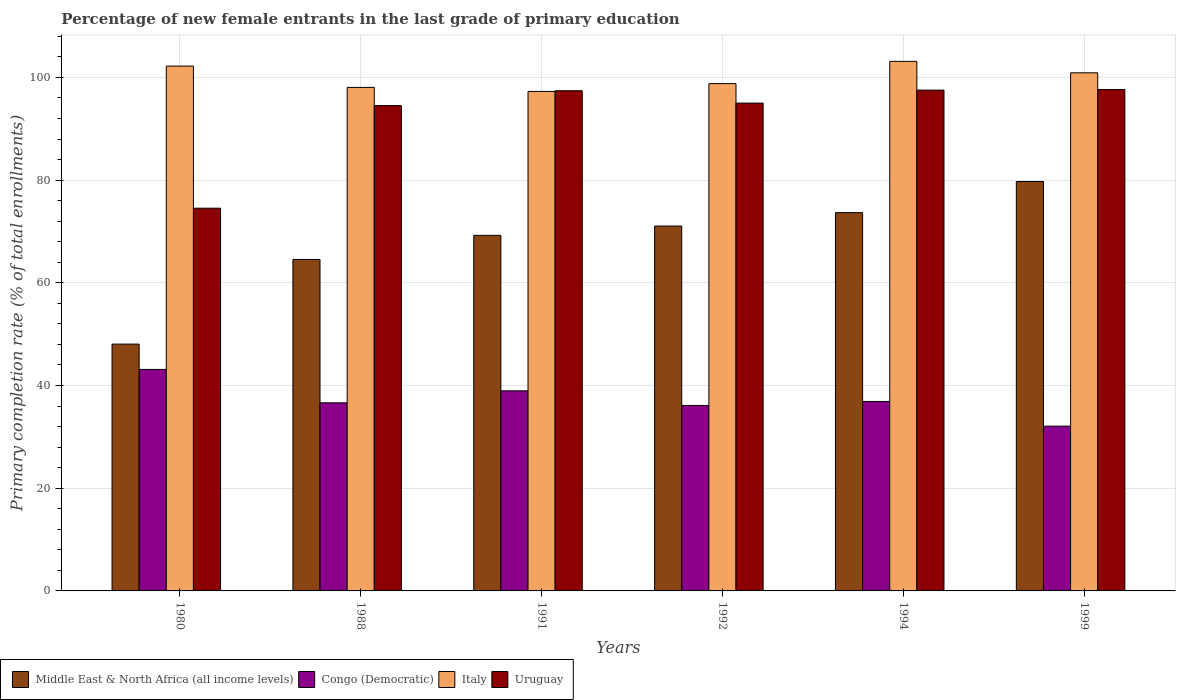Are the number of bars on each tick of the X-axis equal?
Your answer should be very brief. Yes. What is the label of the 5th group of bars from the left?
Keep it short and to the point. 1994. In how many cases, is the number of bars for a given year not equal to the number of legend labels?
Ensure brevity in your answer.  0. What is the percentage of new female entrants in Middle East & North Africa (all income levels) in 1992?
Your answer should be very brief. 71.06. Across all years, what is the maximum percentage of new female entrants in Middle East & North Africa (all income levels)?
Your response must be concise. 79.73. Across all years, what is the minimum percentage of new female entrants in Uruguay?
Your answer should be very brief. 74.53. In which year was the percentage of new female entrants in Italy maximum?
Your answer should be compact. 1994. In which year was the percentage of new female entrants in Uruguay minimum?
Ensure brevity in your answer.  1980. What is the total percentage of new female entrants in Middle East & North Africa (all income levels) in the graph?
Make the answer very short. 406.31. What is the difference between the percentage of new female entrants in Middle East & North Africa (all income levels) in 1991 and that in 1994?
Your answer should be compact. -4.42. What is the difference between the percentage of new female entrants in Congo (Democratic) in 1994 and the percentage of new female entrants in Middle East & North Africa (all income levels) in 1980?
Your answer should be compact. -11.17. What is the average percentage of new female entrants in Uruguay per year?
Your response must be concise. 92.77. In the year 1992, what is the difference between the percentage of new female entrants in Middle East & North Africa (all income levels) and percentage of new female entrants in Uruguay?
Keep it short and to the point. -23.94. In how many years, is the percentage of new female entrants in Congo (Democratic) greater than 60 %?
Keep it short and to the point. 0. What is the ratio of the percentage of new female entrants in Uruguay in 1980 to that in 1994?
Your answer should be compact. 0.76. Is the difference between the percentage of new female entrants in Middle East & North Africa (all income levels) in 1991 and 1999 greater than the difference between the percentage of new female entrants in Uruguay in 1991 and 1999?
Your answer should be very brief. No. What is the difference between the highest and the second highest percentage of new female entrants in Middle East & North Africa (all income levels)?
Ensure brevity in your answer.  6.06. What is the difference between the highest and the lowest percentage of new female entrants in Middle East & North Africa (all income levels)?
Make the answer very short. 31.66. Is the sum of the percentage of new female entrants in Congo (Democratic) in 1988 and 1992 greater than the maximum percentage of new female entrants in Uruguay across all years?
Provide a succinct answer. No. What does the 3rd bar from the left in 1992 represents?
Make the answer very short. Italy. What does the 4th bar from the right in 1999 represents?
Give a very brief answer. Middle East & North Africa (all income levels). Is it the case that in every year, the sum of the percentage of new female entrants in Italy and percentage of new female entrants in Middle East & North Africa (all income levels) is greater than the percentage of new female entrants in Congo (Democratic)?
Give a very brief answer. Yes. How many years are there in the graph?
Offer a very short reply. 6. Are the values on the major ticks of Y-axis written in scientific E-notation?
Make the answer very short. No. Does the graph contain grids?
Keep it short and to the point. Yes. Where does the legend appear in the graph?
Ensure brevity in your answer.  Bottom left. How many legend labels are there?
Make the answer very short. 4. How are the legend labels stacked?
Offer a terse response. Horizontal. What is the title of the graph?
Give a very brief answer. Percentage of new female entrants in the last grade of primary education. Does "Sierra Leone" appear as one of the legend labels in the graph?
Your answer should be very brief. No. What is the label or title of the Y-axis?
Keep it short and to the point. Primary completion rate (% of total enrollments). What is the Primary completion rate (% of total enrollments) of Middle East & North Africa (all income levels) in 1980?
Your answer should be very brief. 48.07. What is the Primary completion rate (% of total enrollments) in Congo (Democratic) in 1980?
Offer a very short reply. 43.14. What is the Primary completion rate (% of total enrollments) in Italy in 1980?
Your answer should be very brief. 102.2. What is the Primary completion rate (% of total enrollments) of Uruguay in 1980?
Your answer should be very brief. 74.53. What is the Primary completion rate (% of total enrollments) of Middle East & North Africa (all income levels) in 1988?
Offer a terse response. 64.55. What is the Primary completion rate (% of total enrollments) of Congo (Democratic) in 1988?
Ensure brevity in your answer.  36.63. What is the Primary completion rate (% of total enrollments) of Italy in 1988?
Ensure brevity in your answer.  98.06. What is the Primary completion rate (% of total enrollments) in Uruguay in 1988?
Your answer should be compact. 94.51. What is the Primary completion rate (% of total enrollments) of Middle East & North Africa (all income levels) in 1991?
Keep it short and to the point. 69.24. What is the Primary completion rate (% of total enrollments) of Congo (Democratic) in 1991?
Give a very brief answer. 38.96. What is the Primary completion rate (% of total enrollments) of Italy in 1991?
Provide a succinct answer. 97.27. What is the Primary completion rate (% of total enrollments) of Uruguay in 1991?
Offer a very short reply. 97.4. What is the Primary completion rate (% of total enrollments) in Middle East & North Africa (all income levels) in 1992?
Offer a very short reply. 71.06. What is the Primary completion rate (% of total enrollments) in Congo (Democratic) in 1992?
Offer a terse response. 36.12. What is the Primary completion rate (% of total enrollments) of Italy in 1992?
Offer a terse response. 98.79. What is the Primary completion rate (% of total enrollments) of Uruguay in 1992?
Keep it short and to the point. 95. What is the Primary completion rate (% of total enrollments) of Middle East & North Africa (all income levels) in 1994?
Ensure brevity in your answer.  73.67. What is the Primary completion rate (% of total enrollments) of Congo (Democratic) in 1994?
Provide a succinct answer. 36.89. What is the Primary completion rate (% of total enrollments) in Italy in 1994?
Offer a very short reply. 103.13. What is the Primary completion rate (% of total enrollments) in Uruguay in 1994?
Provide a succinct answer. 97.53. What is the Primary completion rate (% of total enrollments) of Middle East & North Africa (all income levels) in 1999?
Give a very brief answer. 79.73. What is the Primary completion rate (% of total enrollments) in Congo (Democratic) in 1999?
Offer a very short reply. 32.09. What is the Primary completion rate (% of total enrollments) of Italy in 1999?
Your response must be concise. 100.9. What is the Primary completion rate (% of total enrollments) of Uruguay in 1999?
Your answer should be compact. 97.64. Across all years, what is the maximum Primary completion rate (% of total enrollments) of Middle East & North Africa (all income levels)?
Your answer should be very brief. 79.73. Across all years, what is the maximum Primary completion rate (% of total enrollments) in Congo (Democratic)?
Offer a terse response. 43.14. Across all years, what is the maximum Primary completion rate (% of total enrollments) in Italy?
Your response must be concise. 103.13. Across all years, what is the maximum Primary completion rate (% of total enrollments) of Uruguay?
Make the answer very short. 97.64. Across all years, what is the minimum Primary completion rate (% of total enrollments) in Middle East & North Africa (all income levels)?
Offer a very short reply. 48.07. Across all years, what is the minimum Primary completion rate (% of total enrollments) of Congo (Democratic)?
Ensure brevity in your answer.  32.09. Across all years, what is the minimum Primary completion rate (% of total enrollments) in Italy?
Your response must be concise. 97.27. Across all years, what is the minimum Primary completion rate (% of total enrollments) of Uruguay?
Offer a very short reply. 74.53. What is the total Primary completion rate (% of total enrollments) of Middle East & North Africa (all income levels) in the graph?
Your response must be concise. 406.31. What is the total Primary completion rate (% of total enrollments) of Congo (Democratic) in the graph?
Offer a terse response. 223.83. What is the total Primary completion rate (% of total enrollments) of Italy in the graph?
Your answer should be very brief. 600.35. What is the total Primary completion rate (% of total enrollments) in Uruguay in the graph?
Offer a terse response. 556.6. What is the difference between the Primary completion rate (% of total enrollments) of Middle East & North Africa (all income levels) in 1980 and that in 1988?
Make the answer very short. -16.48. What is the difference between the Primary completion rate (% of total enrollments) of Congo (Democratic) in 1980 and that in 1988?
Give a very brief answer. 6.51. What is the difference between the Primary completion rate (% of total enrollments) in Italy in 1980 and that in 1988?
Your answer should be very brief. 4.15. What is the difference between the Primary completion rate (% of total enrollments) in Uruguay in 1980 and that in 1988?
Offer a terse response. -19.98. What is the difference between the Primary completion rate (% of total enrollments) in Middle East & North Africa (all income levels) in 1980 and that in 1991?
Your answer should be very brief. -21.18. What is the difference between the Primary completion rate (% of total enrollments) of Congo (Democratic) in 1980 and that in 1991?
Your answer should be very brief. 4.17. What is the difference between the Primary completion rate (% of total enrollments) in Italy in 1980 and that in 1991?
Your response must be concise. 4.93. What is the difference between the Primary completion rate (% of total enrollments) of Uruguay in 1980 and that in 1991?
Your response must be concise. -22.87. What is the difference between the Primary completion rate (% of total enrollments) of Middle East & North Africa (all income levels) in 1980 and that in 1992?
Keep it short and to the point. -22.99. What is the difference between the Primary completion rate (% of total enrollments) in Congo (Democratic) in 1980 and that in 1992?
Make the answer very short. 7.02. What is the difference between the Primary completion rate (% of total enrollments) of Italy in 1980 and that in 1992?
Make the answer very short. 3.41. What is the difference between the Primary completion rate (% of total enrollments) of Uruguay in 1980 and that in 1992?
Provide a short and direct response. -20.46. What is the difference between the Primary completion rate (% of total enrollments) in Middle East & North Africa (all income levels) in 1980 and that in 1994?
Your answer should be compact. -25.6. What is the difference between the Primary completion rate (% of total enrollments) of Congo (Democratic) in 1980 and that in 1994?
Provide a short and direct response. 6.24. What is the difference between the Primary completion rate (% of total enrollments) of Italy in 1980 and that in 1994?
Offer a terse response. -0.92. What is the difference between the Primary completion rate (% of total enrollments) of Uruguay in 1980 and that in 1994?
Provide a succinct answer. -22.99. What is the difference between the Primary completion rate (% of total enrollments) of Middle East & North Africa (all income levels) in 1980 and that in 1999?
Offer a very short reply. -31.66. What is the difference between the Primary completion rate (% of total enrollments) in Congo (Democratic) in 1980 and that in 1999?
Provide a short and direct response. 11.05. What is the difference between the Primary completion rate (% of total enrollments) in Italy in 1980 and that in 1999?
Keep it short and to the point. 1.31. What is the difference between the Primary completion rate (% of total enrollments) of Uruguay in 1980 and that in 1999?
Your answer should be compact. -23.11. What is the difference between the Primary completion rate (% of total enrollments) of Middle East & North Africa (all income levels) in 1988 and that in 1991?
Offer a very short reply. -4.69. What is the difference between the Primary completion rate (% of total enrollments) in Congo (Democratic) in 1988 and that in 1991?
Offer a very short reply. -2.33. What is the difference between the Primary completion rate (% of total enrollments) of Italy in 1988 and that in 1991?
Give a very brief answer. 0.79. What is the difference between the Primary completion rate (% of total enrollments) in Uruguay in 1988 and that in 1991?
Offer a very short reply. -2.89. What is the difference between the Primary completion rate (% of total enrollments) of Middle East & North Africa (all income levels) in 1988 and that in 1992?
Provide a succinct answer. -6.5. What is the difference between the Primary completion rate (% of total enrollments) of Congo (Democratic) in 1988 and that in 1992?
Keep it short and to the point. 0.51. What is the difference between the Primary completion rate (% of total enrollments) of Italy in 1988 and that in 1992?
Keep it short and to the point. -0.74. What is the difference between the Primary completion rate (% of total enrollments) in Uruguay in 1988 and that in 1992?
Offer a terse response. -0.48. What is the difference between the Primary completion rate (% of total enrollments) in Middle East & North Africa (all income levels) in 1988 and that in 1994?
Offer a terse response. -9.12. What is the difference between the Primary completion rate (% of total enrollments) in Congo (Democratic) in 1988 and that in 1994?
Provide a succinct answer. -0.27. What is the difference between the Primary completion rate (% of total enrollments) in Italy in 1988 and that in 1994?
Your answer should be very brief. -5.07. What is the difference between the Primary completion rate (% of total enrollments) of Uruguay in 1988 and that in 1994?
Give a very brief answer. -3.01. What is the difference between the Primary completion rate (% of total enrollments) of Middle East & North Africa (all income levels) in 1988 and that in 1999?
Offer a very short reply. -15.18. What is the difference between the Primary completion rate (% of total enrollments) of Congo (Democratic) in 1988 and that in 1999?
Keep it short and to the point. 4.54. What is the difference between the Primary completion rate (% of total enrollments) in Italy in 1988 and that in 1999?
Offer a very short reply. -2.84. What is the difference between the Primary completion rate (% of total enrollments) of Uruguay in 1988 and that in 1999?
Your answer should be very brief. -3.13. What is the difference between the Primary completion rate (% of total enrollments) in Middle East & North Africa (all income levels) in 1991 and that in 1992?
Offer a terse response. -1.81. What is the difference between the Primary completion rate (% of total enrollments) in Congo (Democratic) in 1991 and that in 1992?
Make the answer very short. 2.84. What is the difference between the Primary completion rate (% of total enrollments) of Italy in 1991 and that in 1992?
Give a very brief answer. -1.52. What is the difference between the Primary completion rate (% of total enrollments) in Uruguay in 1991 and that in 1992?
Offer a terse response. 2.41. What is the difference between the Primary completion rate (% of total enrollments) in Middle East & North Africa (all income levels) in 1991 and that in 1994?
Ensure brevity in your answer.  -4.42. What is the difference between the Primary completion rate (% of total enrollments) of Congo (Democratic) in 1991 and that in 1994?
Your answer should be very brief. 2.07. What is the difference between the Primary completion rate (% of total enrollments) in Italy in 1991 and that in 1994?
Your answer should be compact. -5.86. What is the difference between the Primary completion rate (% of total enrollments) of Uruguay in 1991 and that in 1994?
Give a very brief answer. -0.12. What is the difference between the Primary completion rate (% of total enrollments) of Middle East & North Africa (all income levels) in 1991 and that in 1999?
Provide a short and direct response. -10.49. What is the difference between the Primary completion rate (% of total enrollments) in Congo (Democratic) in 1991 and that in 1999?
Provide a short and direct response. 6.88. What is the difference between the Primary completion rate (% of total enrollments) in Italy in 1991 and that in 1999?
Your answer should be compact. -3.63. What is the difference between the Primary completion rate (% of total enrollments) of Uruguay in 1991 and that in 1999?
Your answer should be compact. -0.24. What is the difference between the Primary completion rate (% of total enrollments) of Middle East & North Africa (all income levels) in 1992 and that in 1994?
Offer a terse response. -2.61. What is the difference between the Primary completion rate (% of total enrollments) in Congo (Democratic) in 1992 and that in 1994?
Offer a terse response. -0.78. What is the difference between the Primary completion rate (% of total enrollments) of Italy in 1992 and that in 1994?
Give a very brief answer. -4.33. What is the difference between the Primary completion rate (% of total enrollments) of Uruguay in 1992 and that in 1994?
Offer a terse response. -2.53. What is the difference between the Primary completion rate (% of total enrollments) of Middle East & North Africa (all income levels) in 1992 and that in 1999?
Make the answer very short. -8.67. What is the difference between the Primary completion rate (% of total enrollments) in Congo (Democratic) in 1992 and that in 1999?
Your response must be concise. 4.03. What is the difference between the Primary completion rate (% of total enrollments) in Italy in 1992 and that in 1999?
Offer a terse response. -2.1. What is the difference between the Primary completion rate (% of total enrollments) in Uruguay in 1992 and that in 1999?
Your answer should be compact. -2.64. What is the difference between the Primary completion rate (% of total enrollments) in Middle East & North Africa (all income levels) in 1994 and that in 1999?
Your answer should be compact. -6.06. What is the difference between the Primary completion rate (% of total enrollments) in Congo (Democratic) in 1994 and that in 1999?
Your answer should be very brief. 4.81. What is the difference between the Primary completion rate (% of total enrollments) in Italy in 1994 and that in 1999?
Offer a terse response. 2.23. What is the difference between the Primary completion rate (% of total enrollments) of Uruguay in 1994 and that in 1999?
Offer a terse response. -0.11. What is the difference between the Primary completion rate (% of total enrollments) in Middle East & North Africa (all income levels) in 1980 and the Primary completion rate (% of total enrollments) in Congo (Democratic) in 1988?
Your answer should be very brief. 11.44. What is the difference between the Primary completion rate (% of total enrollments) in Middle East & North Africa (all income levels) in 1980 and the Primary completion rate (% of total enrollments) in Italy in 1988?
Offer a very short reply. -49.99. What is the difference between the Primary completion rate (% of total enrollments) in Middle East & North Africa (all income levels) in 1980 and the Primary completion rate (% of total enrollments) in Uruguay in 1988?
Provide a short and direct response. -46.44. What is the difference between the Primary completion rate (% of total enrollments) in Congo (Democratic) in 1980 and the Primary completion rate (% of total enrollments) in Italy in 1988?
Provide a succinct answer. -54.92. What is the difference between the Primary completion rate (% of total enrollments) of Congo (Democratic) in 1980 and the Primary completion rate (% of total enrollments) of Uruguay in 1988?
Your answer should be compact. -51.37. What is the difference between the Primary completion rate (% of total enrollments) in Italy in 1980 and the Primary completion rate (% of total enrollments) in Uruguay in 1988?
Give a very brief answer. 7.69. What is the difference between the Primary completion rate (% of total enrollments) in Middle East & North Africa (all income levels) in 1980 and the Primary completion rate (% of total enrollments) in Congo (Democratic) in 1991?
Keep it short and to the point. 9.1. What is the difference between the Primary completion rate (% of total enrollments) in Middle East & North Africa (all income levels) in 1980 and the Primary completion rate (% of total enrollments) in Italy in 1991?
Your response must be concise. -49.2. What is the difference between the Primary completion rate (% of total enrollments) of Middle East & North Africa (all income levels) in 1980 and the Primary completion rate (% of total enrollments) of Uruguay in 1991?
Offer a terse response. -49.34. What is the difference between the Primary completion rate (% of total enrollments) in Congo (Democratic) in 1980 and the Primary completion rate (% of total enrollments) in Italy in 1991?
Offer a very short reply. -54.13. What is the difference between the Primary completion rate (% of total enrollments) in Congo (Democratic) in 1980 and the Primary completion rate (% of total enrollments) in Uruguay in 1991?
Your answer should be very brief. -54.27. What is the difference between the Primary completion rate (% of total enrollments) in Italy in 1980 and the Primary completion rate (% of total enrollments) in Uruguay in 1991?
Your answer should be very brief. 4.8. What is the difference between the Primary completion rate (% of total enrollments) of Middle East & North Africa (all income levels) in 1980 and the Primary completion rate (% of total enrollments) of Congo (Democratic) in 1992?
Ensure brevity in your answer.  11.95. What is the difference between the Primary completion rate (% of total enrollments) in Middle East & North Africa (all income levels) in 1980 and the Primary completion rate (% of total enrollments) in Italy in 1992?
Your answer should be very brief. -50.73. What is the difference between the Primary completion rate (% of total enrollments) of Middle East & North Africa (all income levels) in 1980 and the Primary completion rate (% of total enrollments) of Uruguay in 1992?
Offer a very short reply. -46.93. What is the difference between the Primary completion rate (% of total enrollments) of Congo (Democratic) in 1980 and the Primary completion rate (% of total enrollments) of Italy in 1992?
Your answer should be very brief. -55.66. What is the difference between the Primary completion rate (% of total enrollments) in Congo (Democratic) in 1980 and the Primary completion rate (% of total enrollments) in Uruguay in 1992?
Provide a short and direct response. -51.86. What is the difference between the Primary completion rate (% of total enrollments) of Italy in 1980 and the Primary completion rate (% of total enrollments) of Uruguay in 1992?
Your answer should be very brief. 7.21. What is the difference between the Primary completion rate (% of total enrollments) of Middle East & North Africa (all income levels) in 1980 and the Primary completion rate (% of total enrollments) of Congo (Democratic) in 1994?
Offer a very short reply. 11.17. What is the difference between the Primary completion rate (% of total enrollments) of Middle East & North Africa (all income levels) in 1980 and the Primary completion rate (% of total enrollments) of Italy in 1994?
Offer a very short reply. -55.06. What is the difference between the Primary completion rate (% of total enrollments) of Middle East & North Africa (all income levels) in 1980 and the Primary completion rate (% of total enrollments) of Uruguay in 1994?
Ensure brevity in your answer.  -49.46. What is the difference between the Primary completion rate (% of total enrollments) of Congo (Democratic) in 1980 and the Primary completion rate (% of total enrollments) of Italy in 1994?
Provide a succinct answer. -59.99. What is the difference between the Primary completion rate (% of total enrollments) of Congo (Democratic) in 1980 and the Primary completion rate (% of total enrollments) of Uruguay in 1994?
Keep it short and to the point. -54.39. What is the difference between the Primary completion rate (% of total enrollments) in Italy in 1980 and the Primary completion rate (% of total enrollments) in Uruguay in 1994?
Offer a very short reply. 4.68. What is the difference between the Primary completion rate (% of total enrollments) in Middle East & North Africa (all income levels) in 1980 and the Primary completion rate (% of total enrollments) in Congo (Democratic) in 1999?
Provide a short and direct response. 15.98. What is the difference between the Primary completion rate (% of total enrollments) of Middle East & North Africa (all income levels) in 1980 and the Primary completion rate (% of total enrollments) of Italy in 1999?
Make the answer very short. -52.83. What is the difference between the Primary completion rate (% of total enrollments) of Middle East & North Africa (all income levels) in 1980 and the Primary completion rate (% of total enrollments) of Uruguay in 1999?
Ensure brevity in your answer.  -49.57. What is the difference between the Primary completion rate (% of total enrollments) in Congo (Democratic) in 1980 and the Primary completion rate (% of total enrollments) in Italy in 1999?
Offer a very short reply. -57.76. What is the difference between the Primary completion rate (% of total enrollments) in Congo (Democratic) in 1980 and the Primary completion rate (% of total enrollments) in Uruguay in 1999?
Make the answer very short. -54.5. What is the difference between the Primary completion rate (% of total enrollments) of Italy in 1980 and the Primary completion rate (% of total enrollments) of Uruguay in 1999?
Offer a terse response. 4.57. What is the difference between the Primary completion rate (% of total enrollments) of Middle East & North Africa (all income levels) in 1988 and the Primary completion rate (% of total enrollments) of Congo (Democratic) in 1991?
Your response must be concise. 25.59. What is the difference between the Primary completion rate (% of total enrollments) in Middle East & North Africa (all income levels) in 1988 and the Primary completion rate (% of total enrollments) in Italy in 1991?
Provide a succinct answer. -32.72. What is the difference between the Primary completion rate (% of total enrollments) of Middle East & North Africa (all income levels) in 1988 and the Primary completion rate (% of total enrollments) of Uruguay in 1991?
Provide a succinct answer. -32.85. What is the difference between the Primary completion rate (% of total enrollments) of Congo (Democratic) in 1988 and the Primary completion rate (% of total enrollments) of Italy in 1991?
Give a very brief answer. -60.64. What is the difference between the Primary completion rate (% of total enrollments) in Congo (Democratic) in 1988 and the Primary completion rate (% of total enrollments) in Uruguay in 1991?
Provide a short and direct response. -60.77. What is the difference between the Primary completion rate (% of total enrollments) of Italy in 1988 and the Primary completion rate (% of total enrollments) of Uruguay in 1991?
Keep it short and to the point. 0.65. What is the difference between the Primary completion rate (% of total enrollments) of Middle East & North Africa (all income levels) in 1988 and the Primary completion rate (% of total enrollments) of Congo (Democratic) in 1992?
Your response must be concise. 28.43. What is the difference between the Primary completion rate (% of total enrollments) of Middle East & North Africa (all income levels) in 1988 and the Primary completion rate (% of total enrollments) of Italy in 1992?
Give a very brief answer. -34.24. What is the difference between the Primary completion rate (% of total enrollments) of Middle East & North Africa (all income levels) in 1988 and the Primary completion rate (% of total enrollments) of Uruguay in 1992?
Your answer should be compact. -30.44. What is the difference between the Primary completion rate (% of total enrollments) in Congo (Democratic) in 1988 and the Primary completion rate (% of total enrollments) in Italy in 1992?
Make the answer very short. -62.16. What is the difference between the Primary completion rate (% of total enrollments) in Congo (Democratic) in 1988 and the Primary completion rate (% of total enrollments) in Uruguay in 1992?
Ensure brevity in your answer.  -58.37. What is the difference between the Primary completion rate (% of total enrollments) of Italy in 1988 and the Primary completion rate (% of total enrollments) of Uruguay in 1992?
Your response must be concise. 3.06. What is the difference between the Primary completion rate (% of total enrollments) of Middle East & North Africa (all income levels) in 1988 and the Primary completion rate (% of total enrollments) of Congo (Democratic) in 1994?
Your answer should be very brief. 27.66. What is the difference between the Primary completion rate (% of total enrollments) in Middle East & North Africa (all income levels) in 1988 and the Primary completion rate (% of total enrollments) in Italy in 1994?
Provide a succinct answer. -38.57. What is the difference between the Primary completion rate (% of total enrollments) of Middle East & North Africa (all income levels) in 1988 and the Primary completion rate (% of total enrollments) of Uruguay in 1994?
Offer a terse response. -32.97. What is the difference between the Primary completion rate (% of total enrollments) of Congo (Democratic) in 1988 and the Primary completion rate (% of total enrollments) of Italy in 1994?
Ensure brevity in your answer.  -66.5. What is the difference between the Primary completion rate (% of total enrollments) of Congo (Democratic) in 1988 and the Primary completion rate (% of total enrollments) of Uruguay in 1994?
Provide a short and direct response. -60.9. What is the difference between the Primary completion rate (% of total enrollments) of Italy in 1988 and the Primary completion rate (% of total enrollments) of Uruguay in 1994?
Offer a terse response. 0.53. What is the difference between the Primary completion rate (% of total enrollments) in Middle East & North Africa (all income levels) in 1988 and the Primary completion rate (% of total enrollments) in Congo (Democratic) in 1999?
Keep it short and to the point. 32.46. What is the difference between the Primary completion rate (% of total enrollments) of Middle East & North Africa (all income levels) in 1988 and the Primary completion rate (% of total enrollments) of Italy in 1999?
Ensure brevity in your answer.  -36.34. What is the difference between the Primary completion rate (% of total enrollments) in Middle East & North Africa (all income levels) in 1988 and the Primary completion rate (% of total enrollments) in Uruguay in 1999?
Make the answer very short. -33.09. What is the difference between the Primary completion rate (% of total enrollments) in Congo (Democratic) in 1988 and the Primary completion rate (% of total enrollments) in Italy in 1999?
Give a very brief answer. -64.27. What is the difference between the Primary completion rate (% of total enrollments) of Congo (Democratic) in 1988 and the Primary completion rate (% of total enrollments) of Uruguay in 1999?
Provide a short and direct response. -61.01. What is the difference between the Primary completion rate (% of total enrollments) of Italy in 1988 and the Primary completion rate (% of total enrollments) of Uruguay in 1999?
Your answer should be very brief. 0.42. What is the difference between the Primary completion rate (% of total enrollments) in Middle East & North Africa (all income levels) in 1991 and the Primary completion rate (% of total enrollments) in Congo (Democratic) in 1992?
Your answer should be very brief. 33.12. What is the difference between the Primary completion rate (% of total enrollments) of Middle East & North Africa (all income levels) in 1991 and the Primary completion rate (% of total enrollments) of Italy in 1992?
Provide a succinct answer. -29.55. What is the difference between the Primary completion rate (% of total enrollments) of Middle East & North Africa (all income levels) in 1991 and the Primary completion rate (% of total enrollments) of Uruguay in 1992?
Your answer should be compact. -25.75. What is the difference between the Primary completion rate (% of total enrollments) of Congo (Democratic) in 1991 and the Primary completion rate (% of total enrollments) of Italy in 1992?
Make the answer very short. -59.83. What is the difference between the Primary completion rate (% of total enrollments) in Congo (Democratic) in 1991 and the Primary completion rate (% of total enrollments) in Uruguay in 1992?
Provide a short and direct response. -56.03. What is the difference between the Primary completion rate (% of total enrollments) of Italy in 1991 and the Primary completion rate (% of total enrollments) of Uruguay in 1992?
Offer a very short reply. 2.27. What is the difference between the Primary completion rate (% of total enrollments) in Middle East & North Africa (all income levels) in 1991 and the Primary completion rate (% of total enrollments) in Congo (Democratic) in 1994?
Provide a succinct answer. 32.35. What is the difference between the Primary completion rate (% of total enrollments) of Middle East & North Africa (all income levels) in 1991 and the Primary completion rate (% of total enrollments) of Italy in 1994?
Ensure brevity in your answer.  -33.88. What is the difference between the Primary completion rate (% of total enrollments) in Middle East & North Africa (all income levels) in 1991 and the Primary completion rate (% of total enrollments) in Uruguay in 1994?
Keep it short and to the point. -28.28. What is the difference between the Primary completion rate (% of total enrollments) of Congo (Democratic) in 1991 and the Primary completion rate (% of total enrollments) of Italy in 1994?
Your answer should be compact. -64.16. What is the difference between the Primary completion rate (% of total enrollments) in Congo (Democratic) in 1991 and the Primary completion rate (% of total enrollments) in Uruguay in 1994?
Provide a succinct answer. -58.56. What is the difference between the Primary completion rate (% of total enrollments) in Italy in 1991 and the Primary completion rate (% of total enrollments) in Uruguay in 1994?
Offer a terse response. -0.25. What is the difference between the Primary completion rate (% of total enrollments) of Middle East & North Africa (all income levels) in 1991 and the Primary completion rate (% of total enrollments) of Congo (Democratic) in 1999?
Provide a succinct answer. 37.16. What is the difference between the Primary completion rate (% of total enrollments) of Middle East & North Africa (all income levels) in 1991 and the Primary completion rate (% of total enrollments) of Italy in 1999?
Give a very brief answer. -31.65. What is the difference between the Primary completion rate (% of total enrollments) in Middle East & North Africa (all income levels) in 1991 and the Primary completion rate (% of total enrollments) in Uruguay in 1999?
Ensure brevity in your answer.  -28.4. What is the difference between the Primary completion rate (% of total enrollments) of Congo (Democratic) in 1991 and the Primary completion rate (% of total enrollments) of Italy in 1999?
Ensure brevity in your answer.  -61.93. What is the difference between the Primary completion rate (% of total enrollments) of Congo (Democratic) in 1991 and the Primary completion rate (% of total enrollments) of Uruguay in 1999?
Your response must be concise. -58.68. What is the difference between the Primary completion rate (% of total enrollments) of Italy in 1991 and the Primary completion rate (% of total enrollments) of Uruguay in 1999?
Offer a terse response. -0.37. What is the difference between the Primary completion rate (% of total enrollments) of Middle East & North Africa (all income levels) in 1992 and the Primary completion rate (% of total enrollments) of Congo (Democratic) in 1994?
Offer a very short reply. 34.16. What is the difference between the Primary completion rate (% of total enrollments) of Middle East & North Africa (all income levels) in 1992 and the Primary completion rate (% of total enrollments) of Italy in 1994?
Your answer should be compact. -32.07. What is the difference between the Primary completion rate (% of total enrollments) in Middle East & North Africa (all income levels) in 1992 and the Primary completion rate (% of total enrollments) in Uruguay in 1994?
Offer a terse response. -26.47. What is the difference between the Primary completion rate (% of total enrollments) of Congo (Democratic) in 1992 and the Primary completion rate (% of total enrollments) of Italy in 1994?
Offer a very short reply. -67.01. What is the difference between the Primary completion rate (% of total enrollments) in Congo (Democratic) in 1992 and the Primary completion rate (% of total enrollments) in Uruguay in 1994?
Your answer should be very brief. -61.41. What is the difference between the Primary completion rate (% of total enrollments) in Italy in 1992 and the Primary completion rate (% of total enrollments) in Uruguay in 1994?
Your answer should be very brief. 1.27. What is the difference between the Primary completion rate (% of total enrollments) of Middle East & North Africa (all income levels) in 1992 and the Primary completion rate (% of total enrollments) of Congo (Democratic) in 1999?
Provide a short and direct response. 38.97. What is the difference between the Primary completion rate (% of total enrollments) in Middle East & North Africa (all income levels) in 1992 and the Primary completion rate (% of total enrollments) in Italy in 1999?
Your response must be concise. -29.84. What is the difference between the Primary completion rate (% of total enrollments) of Middle East & North Africa (all income levels) in 1992 and the Primary completion rate (% of total enrollments) of Uruguay in 1999?
Give a very brief answer. -26.58. What is the difference between the Primary completion rate (% of total enrollments) in Congo (Democratic) in 1992 and the Primary completion rate (% of total enrollments) in Italy in 1999?
Provide a short and direct response. -64.78. What is the difference between the Primary completion rate (% of total enrollments) in Congo (Democratic) in 1992 and the Primary completion rate (% of total enrollments) in Uruguay in 1999?
Provide a short and direct response. -61.52. What is the difference between the Primary completion rate (% of total enrollments) of Italy in 1992 and the Primary completion rate (% of total enrollments) of Uruguay in 1999?
Your answer should be compact. 1.15. What is the difference between the Primary completion rate (% of total enrollments) of Middle East & North Africa (all income levels) in 1994 and the Primary completion rate (% of total enrollments) of Congo (Democratic) in 1999?
Your answer should be compact. 41.58. What is the difference between the Primary completion rate (% of total enrollments) of Middle East & North Africa (all income levels) in 1994 and the Primary completion rate (% of total enrollments) of Italy in 1999?
Your response must be concise. -27.23. What is the difference between the Primary completion rate (% of total enrollments) of Middle East & North Africa (all income levels) in 1994 and the Primary completion rate (% of total enrollments) of Uruguay in 1999?
Provide a short and direct response. -23.97. What is the difference between the Primary completion rate (% of total enrollments) in Congo (Democratic) in 1994 and the Primary completion rate (% of total enrollments) in Italy in 1999?
Your response must be concise. -64. What is the difference between the Primary completion rate (% of total enrollments) of Congo (Democratic) in 1994 and the Primary completion rate (% of total enrollments) of Uruguay in 1999?
Offer a terse response. -60.74. What is the difference between the Primary completion rate (% of total enrollments) of Italy in 1994 and the Primary completion rate (% of total enrollments) of Uruguay in 1999?
Provide a short and direct response. 5.49. What is the average Primary completion rate (% of total enrollments) in Middle East & North Africa (all income levels) per year?
Your response must be concise. 67.72. What is the average Primary completion rate (% of total enrollments) in Congo (Democratic) per year?
Provide a short and direct response. 37.31. What is the average Primary completion rate (% of total enrollments) in Italy per year?
Provide a short and direct response. 100.06. What is the average Primary completion rate (% of total enrollments) of Uruguay per year?
Offer a very short reply. 92.77. In the year 1980, what is the difference between the Primary completion rate (% of total enrollments) of Middle East & North Africa (all income levels) and Primary completion rate (% of total enrollments) of Congo (Democratic)?
Provide a succinct answer. 4.93. In the year 1980, what is the difference between the Primary completion rate (% of total enrollments) of Middle East & North Africa (all income levels) and Primary completion rate (% of total enrollments) of Italy?
Provide a short and direct response. -54.14. In the year 1980, what is the difference between the Primary completion rate (% of total enrollments) of Middle East & North Africa (all income levels) and Primary completion rate (% of total enrollments) of Uruguay?
Your answer should be compact. -26.46. In the year 1980, what is the difference between the Primary completion rate (% of total enrollments) of Congo (Democratic) and Primary completion rate (% of total enrollments) of Italy?
Give a very brief answer. -59.07. In the year 1980, what is the difference between the Primary completion rate (% of total enrollments) of Congo (Democratic) and Primary completion rate (% of total enrollments) of Uruguay?
Offer a terse response. -31.39. In the year 1980, what is the difference between the Primary completion rate (% of total enrollments) of Italy and Primary completion rate (% of total enrollments) of Uruguay?
Provide a short and direct response. 27.67. In the year 1988, what is the difference between the Primary completion rate (% of total enrollments) in Middle East & North Africa (all income levels) and Primary completion rate (% of total enrollments) in Congo (Democratic)?
Provide a succinct answer. 27.92. In the year 1988, what is the difference between the Primary completion rate (% of total enrollments) of Middle East & North Africa (all income levels) and Primary completion rate (% of total enrollments) of Italy?
Your response must be concise. -33.5. In the year 1988, what is the difference between the Primary completion rate (% of total enrollments) in Middle East & North Africa (all income levels) and Primary completion rate (% of total enrollments) in Uruguay?
Ensure brevity in your answer.  -29.96. In the year 1988, what is the difference between the Primary completion rate (% of total enrollments) of Congo (Democratic) and Primary completion rate (% of total enrollments) of Italy?
Offer a very short reply. -61.43. In the year 1988, what is the difference between the Primary completion rate (% of total enrollments) of Congo (Democratic) and Primary completion rate (% of total enrollments) of Uruguay?
Your response must be concise. -57.88. In the year 1988, what is the difference between the Primary completion rate (% of total enrollments) in Italy and Primary completion rate (% of total enrollments) in Uruguay?
Your answer should be compact. 3.54. In the year 1991, what is the difference between the Primary completion rate (% of total enrollments) in Middle East & North Africa (all income levels) and Primary completion rate (% of total enrollments) in Congo (Democratic)?
Keep it short and to the point. 30.28. In the year 1991, what is the difference between the Primary completion rate (% of total enrollments) in Middle East & North Africa (all income levels) and Primary completion rate (% of total enrollments) in Italy?
Give a very brief answer. -28.03. In the year 1991, what is the difference between the Primary completion rate (% of total enrollments) of Middle East & North Africa (all income levels) and Primary completion rate (% of total enrollments) of Uruguay?
Make the answer very short. -28.16. In the year 1991, what is the difference between the Primary completion rate (% of total enrollments) of Congo (Democratic) and Primary completion rate (% of total enrollments) of Italy?
Make the answer very short. -58.31. In the year 1991, what is the difference between the Primary completion rate (% of total enrollments) in Congo (Democratic) and Primary completion rate (% of total enrollments) in Uruguay?
Provide a short and direct response. -58.44. In the year 1991, what is the difference between the Primary completion rate (% of total enrollments) in Italy and Primary completion rate (% of total enrollments) in Uruguay?
Your answer should be compact. -0.13. In the year 1992, what is the difference between the Primary completion rate (% of total enrollments) of Middle East & North Africa (all income levels) and Primary completion rate (% of total enrollments) of Congo (Democratic)?
Keep it short and to the point. 34.94. In the year 1992, what is the difference between the Primary completion rate (% of total enrollments) of Middle East & North Africa (all income levels) and Primary completion rate (% of total enrollments) of Italy?
Offer a very short reply. -27.74. In the year 1992, what is the difference between the Primary completion rate (% of total enrollments) in Middle East & North Africa (all income levels) and Primary completion rate (% of total enrollments) in Uruguay?
Ensure brevity in your answer.  -23.94. In the year 1992, what is the difference between the Primary completion rate (% of total enrollments) in Congo (Democratic) and Primary completion rate (% of total enrollments) in Italy?
Make the answer very short. -62.67. In the year 1992, what is the difference between the Primary completion rate (% of total enrollments) of Congo (Democratic) and Primary completion rate (% of total enrollments) of Uruguay?
Make the answer very short. -58.88. In the year 1992, what is the difference between the Primary completion rate (% of total enrollments) of Italy and Primary completion rate (% of total enrollments) of Uruguay?
Make the answer very short. 3.8. In the year 1994, what is the difference between the Primary completion rate (% of total enrollments) of Middle East & North Africa (all income levels) and Primary completion rate (% of total enrollments) of Congo (Democratic)?
Your answer should be compact. 36.77. In the year 1994, what is the difference between the Primary completion rate (% of total enrollments) of Middle East & North Africa (all income levels) and Primary completion rate (% of total enrollments) of Italy?
Your answer should be very brief. -29.46. In the year 1994, what is the difference between the Primary completion rate (% of total enrollments) in Middle East & North Africa (all income levels) and Primary completion rate (% of total enrollments) in Uruguay?
Your response must be concise. -23.86. In the year 1994, what is the difference between the Primary completion rate (% of total enrollments) in Congo (Democratic) and Primary completion rate (% of total enrollments) in Italy?
Give a very brief answer. -66.23. In the year 1994, what is the difference between the Primary completion rate (% of total enrollments) in Congo (Democratic) and Primary completion rate (% of total enrollments) in Uruguay?
Keep it short and to the point. -60.63. In the year 1994, what is the difference between the Primary completion rate (% of total enrollments) in Italy and Primary completion rate (% of total enrollments) in Uruguay?
Offer a terse response. 5.6. In the year 1999, what is the difference between the Primary completion rate (% of total enrollments) of Middle East & North Africa (all income levels) and Primary completion rate (% of total enrollments) of Congo (Democratic)?
Your answer should be very brief. 47.64. In the year 1999, what is the difference between the Primary completion rate (% of total enrollments) of Middle East & North Africa (all income levels) and Primary completion rate (% of total enrollments) of Italy?
Your response must be concise. -21.17. In the year 1999, what is the difference between the Primary completion rate (% of total enrollments) of Middle East & North Africa (all income levels) and Primary completion rate (% of total enrollments) of Uruguay?
Give a very brief answer. -17.91. In the year 1999, what is the difference between the Primary completion rate (% of total enrollments) of Congo (Democratic) and Primary completion rate (% of total enrollments) of Italy?
Offer a very short reply. -68.81. In the year 1999, what is the difference between the Primary completion rate (% of total enrollments) of Congo (Democratic) and Primary completion rate (% of total enrollments) of Uruguay?
Your response must be concise. -65.55. In the year 1999, what is the difference between the Primary completion rate (% of total enrollments) in Italy and Primary completion rate (% of total enrollments) in Uruguay?
Your response must be concise. 3.26. What is the ratio of the Primary completion rate (% of total enrollments) of Middle East & North Africa (all income levels) in 1980 to that in 1988?
Give a very brief answer. 0.74. What is the ratio of the Primary completion rate (% of total enrollments) in Congo (Democratic) in 1980 to that in 1988?
Your answer should be very brief. 1.18. What is the ratio of the Primary completion rate (% of total enrollments) of Italy in 1980 to that in 1988?
Give a very brief answer. 1.04. What is the ratio of the Primary completion rate (% of total enrollments) in Uruguay in 1980 to that in 1988?
Keep it short and to the point. 0.79. What is the ratio of the Primary completion rate (% of total enrollments) in Middle East & North Africa (all income levels) in 1980 to that in 1991?
Your answer should be compact. 0.69. What is the ratio of the Primary completion rate (% of total enrollments) in Congo (Democratic) in 1980 to that in 1991?
Ensure brevity in your answer.  1.11. What is the ratio of the Primary completion rate (% of total enrollments) of Italy in 1980 to that in 1991?
Provide a succinct answer. 1.05. What is the ratio of the Primary completion rate (% of total enrollments) in Uruguay in 1980 to that in 1991?
Your answer should be very brief. 0.77. What is the ratio of the Primary completion rate (% of total enrollments) of Middle East & North Africa (all income levels) in 1980 to that in 1992?
Your response must be concise. 0.68. What is the ratio of the Primary completion rate (% of total enrollments) in Congo (Democratic) in 1980 to that in 1992?
Your response must be concise. 1.19. What is the ratio of the Primary completion rate (% of total enrollments) in Italy in 1980 to that in 1992?
Your answer should be compact. 1.03. What is the ratio of the Primary completion rate (% of total enrollments) in Uruguay in 1980 to that in 1992?
Keep it short and to the point. 0.78. What is the ratio of the Primary completion rate (% of total enrollments) in Middle East & North Africa (all income levels) in 1980 to that in 1994?
Make the answer very short. 0.65. What is the ratio of the Primary completion rate (% of total enrollments) of Congo (Democratic) in 1980 to that in 1994?
Your response must be concise. 1.17. What is the ratio of the Primary completion rate (% of total enrollments) in Uruguay in 1980 to that in 1994?
Provide a short and direct response. 0.76. What is the ratio of the Primary completion rate (% of total enrollments) of Middle East & North Africa (all income levels) in 1980 to that in 1999?
Provide a short and direct response. 0.6. What is the ratio of the Primary completion rate (% of total enrollments) of Congo (Democratic) in 1980 to that in 1999?
Provide a succinct answer. 1.34. What is the ratio of the Primary completion rate (% of total enrollments) of Italy in 1980 to that in 1999?
Offer a very short reply. 1.01. What is the ratio of the Primary completion rate (% of total enrollments) of Uruguay in 1980 to that in 1999?
Your answer should be very brief. 0.76. What is the ratio of the Primary completion rate (% of total enrollments) of Middle East & North Africa (all income levels) in 1988 to that in 1991?
Make the answer very short. 0.93. What is the ratio of the Primary completion rate (% of total enrollments) of Congo (Democratic) in 1988 to that in 1991?
Ensure brevity in your answer.  0.94. What is the ratio of the Primary completion rate (% of total enrollments) of Uruguay in 1988 to that in 1991?
Offer a terse response. 0.97. What is the ratio of the Primary completion rate (% of total enrollments) in Middle East & North Africa (all income levels) in 1988 to that in 1992?
Make the answer very short. 0.91. What is the ratio of the Primary completion rate (% of total enrollments) of Congo (Democratic) in 1988 to that in 1992?
Provide a short and direct response. 1.01. What is the ratio of the Primary completion rate (% of total enrollments) of Uruguay in 1988 to that in 1992?
Keep it short and to the point. 0.99. What is the ratio of the Primary completion rate (% of total enrollments) of Middle East & North Africa (all income levels) in 1988 to that in 1994?
Your answer should be compact. 0.88. What is the ratio of the Primary completion rate (% of total enrollments) in Congo (Democratic) in 1988 to that in 1994?
Provide a short and direct response. 0.99. What is the ratio of the Primary completion rate (% of total enrollments) in Italy in 1988 to that in 1994?
Provide a short and direct response. 0.95. What is the ratio of the Primary completion rate (% of total enrollments) in Uruguay in 1988 to that in 1994?
Your response must be concise. 0.97. What is the ratio of the Primary completion rate (% of total enrollments) in Middle East & North Africa (all income levels) in 1988 to that in 1999?
Offer a terse response. 0.81. What is the ratio of the Primary completion rate (% of total enrollments) of Congo (Democratic) in 1988 to that in 1999?
Ensure brevity in your answer.  1.14. What is the ratio of the Primary completion rate (% of total enrollments) in Italy in 1988 to that in 1999?
Give a very brief answer. 0.97. What is the ratio of the Primary completion rate (% of total enrollments) of Middle East & North Africa (all income levels) in 1991 to that in 1992?
Keep it short and to the point. 0.97. What is the ratio of the Primary completion rate (% of total enrollments) of Congo (Democratic) in 1991 to that in 1992?
Give a very brief answer. 1.08. What is the ratio of the Primary completion rate (% of total enrollments) of Italy in 1991 to that in 1992?
Ensure brevity in your answer.  0.98. What is the ratio of the Primary completion rate (% of total enrollments) of Uruguay in 1991 to that in 1992?
Keep it short and to the point. 1.03. What is the ratio of the Primary completion rate (% of total enrollments) of Middle East & North Africa (all income levels) in 1991 to that in 1994?
Make the answer very short. 0.94. What is the ratio of the Primary completion rate (% of total enrollments) in Congo (Democratic) in 1991 to that in 1994?
Keep it short and to the point. 1.06. What is the ratio of the Primary completion rate (% of total enrollments) of Italy in 1991 to that in 1994?
Your answer should be compact. 0.94. What is the ratio of the Primary completion rate (% of total enrollments) in Uruguay in 1991 to that in 1994?
Your answer should be compact. 1. What is the ratio of the Primary completion rate (% of total enrollments) of Middle East & North Africa (all income levels) in 1991 to that in 1999?
Make the answer very short. 0.87. What is the ratio of the Primary completion rate (% of total enrollments) in Congo (Democratic) in 1991 to that in 1999?
Ensure brevity in your answer.  1.21. What is the ratio of the Primary completion rate (% of total enrollments) in Italy in 1991 to that in 1999?
Give a very brief answer. 0.96. What is the ratio of the Primary completion rate (% of total enrollments) of Uruguay in 1991 to that in 1999?
Provide a succinct answer. 1. What is the ratio of the Primary completion rate (% of total enrollments) of Middle East & North Africa (all income levels) in 1992 to that in 1994?
Give a very brief answer. 0.96. What is the ratio of the Primary completion rate (% of total enrollments) of Italy in 1992 to that in 1994?
Make the answer very short. 0.96. What is the ratio of the Primary completion rate (% of total enrollments) of Uruguay in 1992 to that in 1994?
Keep it short and to the point. 0.97. What is the ratio of the Primary completion rate (% of total enrollments) of Middle East & North Africa (all income levels) in 1992 to that in 1999?
Provide a short and direct response. 0.89. What is the ratio of the Primary completion rate (% of total enrollments) in Congo (Democratic) in 1992 to that in 1999?
Offer a terse response. 1.13. What is the ratio of the Primary completion rate (% of total enrollments) in Italy in 1992 to that in 1999?
Your response must be concise. 0.98. What is the ratio of the Primary completion rate (% of total enrollments) in Uruguay in 1992 to that in 1999?
Keep it short and to the point. 0.97. What is the ratio of the Primary completion rate (% of total enrollments) of Middle East & North Africa (all income levels) in 1994 to that in 1999?
Offer a very short reply. 0.92. What is the ratio of the Primary completion rate (% of total enrollments) of Congo (Democratic) in 1994 to that in 1999?
Offer a very short reply. 1.15. What is the ratio of the Primary completion rate (% of total enrollments) of Italy in 1994 to that in 1999?
Ensure brevity in your answer.  1.02. What is the difference between the highest and the second highest Primary completion rate (% of total enrollments) in Middle East & North Africa (all income levels)?
Give a very brief answer. 6.06. What is the difference between the highest and the second highest Primary completion rate (% of total enrollments) in Congo (Democratic)?
Ensure brevity in your answer.  4.17. What is the difference between the highest and the second highest Primary completion rate (% of total enrollments) in Italy?
Make the answer very short. 0.92. What is the difference between the highest and the second highest Primary completion rate (% of total enrollments) in Uruguay?
Your response must be concise. 0.11. What is the difference between the highest and the lowest Primary completion rate (% of total enrollments) of Middle East & North Africa (all income levels)?
Your response must be concise. 31.66. What is the difference between the highest and the lowest Primary completion rate (% of total enrollments) in Congo (Democratic)?
Your answer should be compact. 11.05. What is the difference between the highest and the lowest Primary completion rate (% of total enrollments) of Italy?
Ensure brevity in your answer.  5.86. What is the difference between the highest and the lowest Primary completion rate (% of total enrollments) in Uruguay?
Offer a terse response. 23.11. 